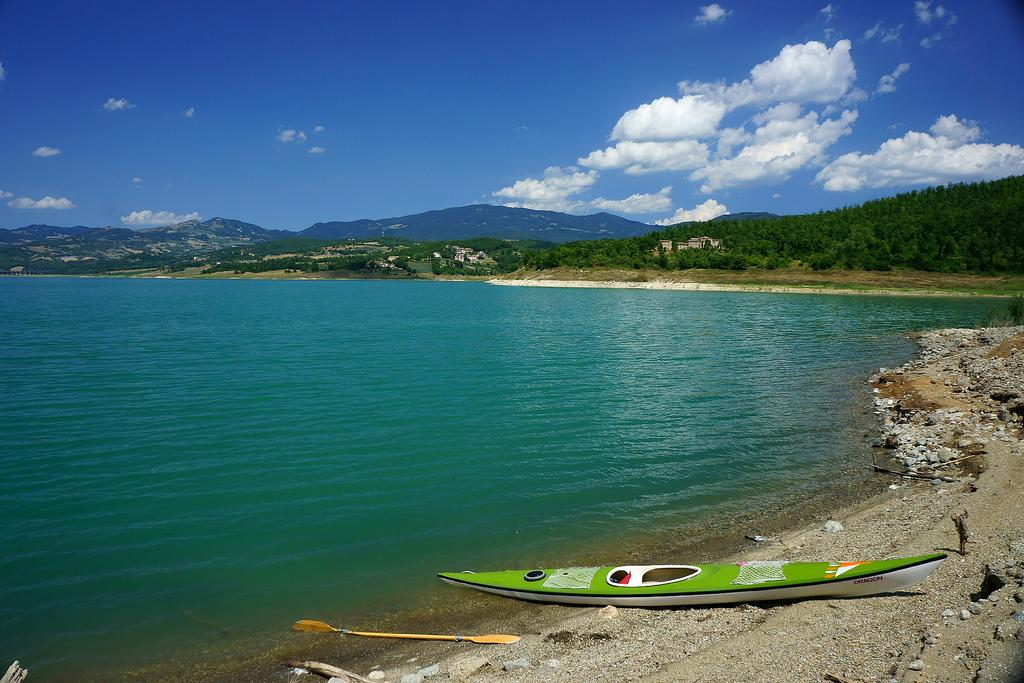What type of natural body of water is in the image? There is a sea in the image. What type of vegetation is present around the sea? Trees are present around the sea. What geographical features can be seen in the image? Mountains are visible in the image. What type of vehicle is located on the sea shore? There is a boat on the sea shore. What is the color of the sky in the image? The sky is blue in the image. Can you see a comb being used by a snail in the image? There is no comb or snail present in the image. 